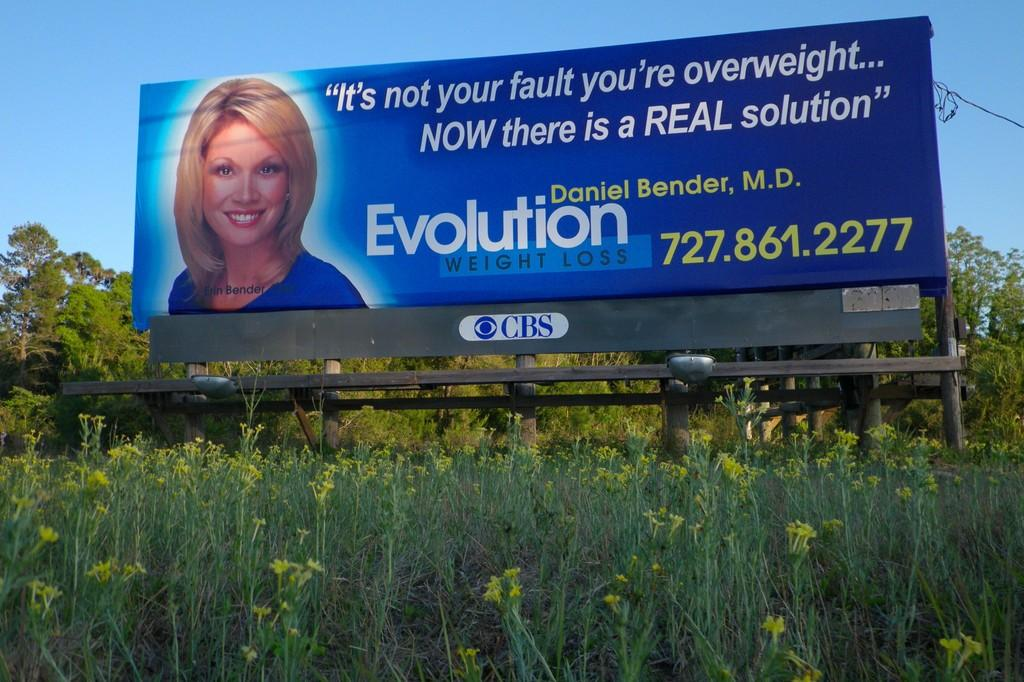<image>
Relay a brief, clear account of the picture shown. a bill board for Evolution Weight loss in a flowery field 